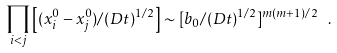<formula> <loc_0><loc_0><loc_500><loc_500>\prod _ { i < j } \left [ ( x _ { i } ^ { 0 } - x _ { j } ^ { 0 } ) / ( D t ) ^ { 1 / 2 } \right ] \sim [ b _ { 0 } / ( D t ) ^ { 1 / 2 } ] ^ { m ( m + 1 ) / 2 } \ .</formula> 